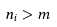<formula> <loc_0><loc_0><loc_500><loc_500>n _ { i } > m</formula> 